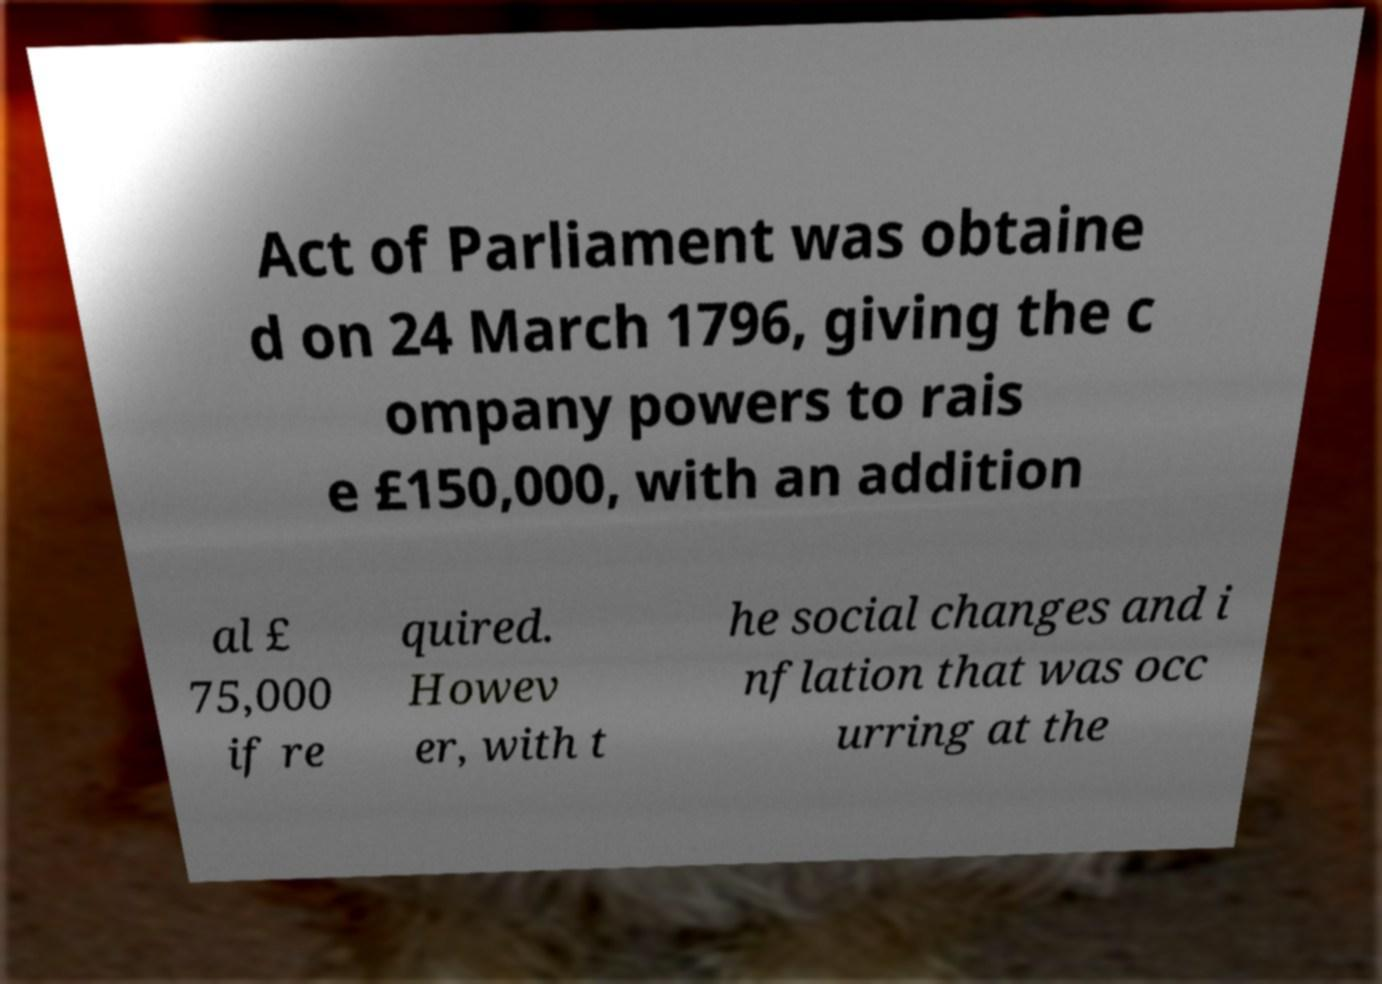Please read and relay the text visible in this image. What does it say? Act of Parliament was obtaine d on 24 March 1796, giving the c ompany powers to rais e £150,000, with an addition al £ 75,000 if re quired. Howev er, with t he social changes and i nflation that was occ urring at the 